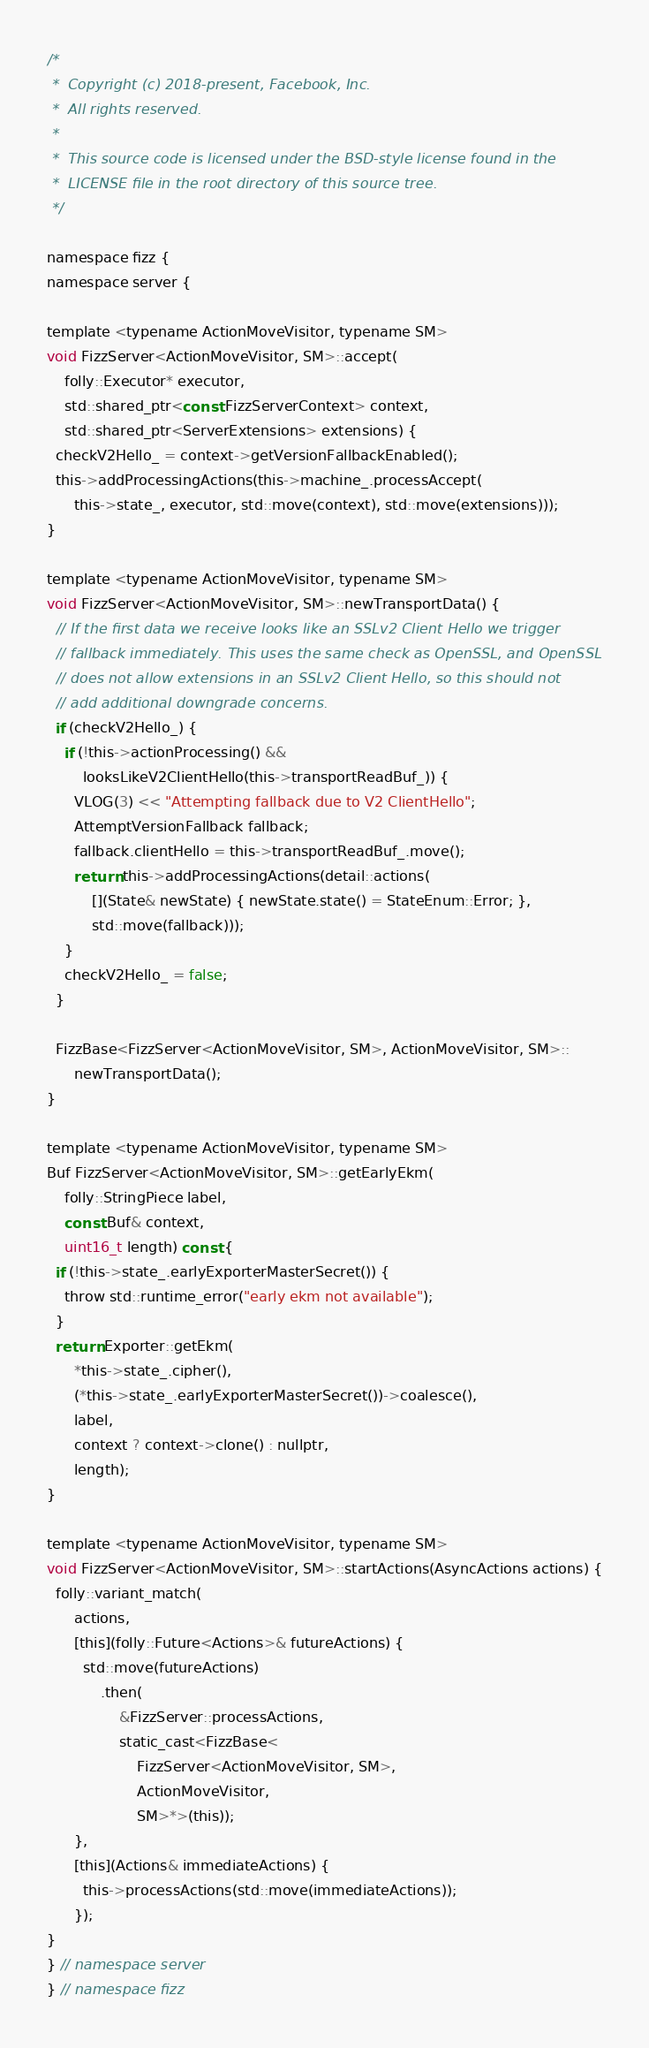Convert code to text. <code><loc_0><loc_0><loc_500><loc_500><_C_>/*
 *  Copyright (c) 2018-present, Facebook, Inc.
 *  All rights reserved.
 *
 *  This source code is licensed under the BSD-style license found in the
 *  LICENSE file in the root directory of this source tree.
 */

namespace fizz {
namespace server {

template <typename ActionMoveVisitor, typename SM>
void FizzServer<ActionMoveVisitor, SM>::accept(
    folly::Executor* executor,
    std::shared_ptr<const FizzServerContext> context,
    std::shared_ptr<ServerExtensions> extensions) {
  checkV2Hello_ = context->getVersionFallbackEnabled();
  this->addProcessingActions(this->machine_.processAccept(
      this->state_, executor, std::move(context), std::move(extensions)));
}

template <typename ActionMoveVisitor, typename SM>
void FizzServer<ActionMoveVisitor, SM>::newTransportData() {
  // If the first data we receive looks like an SSLv2 Client Hello we trigger
  // fallback immediately. This uses the same check as OpenSSL, and OpenSSL
  // does not allow extensions in an SSLv2 Client Hello, so this should not
  // add additional downgrade concerns.
  if (checkV2Hello_) {
    if (!this->actionProcessing() &&
        looksLikeV2ClientHello(this->transportReadBuf_)) {
      VLOG(3) << "Attempting fallback due to V2 ClientHello";
      AttemptVersionFallback fallback;
      fallback.clientHello = this->transportReadBuf_.move();
      return this->addProcessingActions(detail::actions(
          [](State& newState) { newState.state() = StateEnum::Error; },
          std::move(fallback)));
    }
    checkV2Hello_ = false;
  }

  FizzBase<FizzServer<ActionMoveVisitor, SM>, ActionMoveVisitor, SM>::
      newTransportData();
}

template <typename ActionMoveVisitor, typename SM>
Buf FizzServer<ActionMoveVisitor, SM>::getEarlyEkm(
    folly::StringPiece label,
    const Buf& context,
    uint16_t length) const {
  if (!this->state_.earlyExporterMasterSecret()) {
    throw std::runtime_error("early ekm not available");
  }
  return Exporter::getEkm(
      *this->state_.cipher(),
      (*this->state_.earlyExporterMasterSecret())->coalesce(),
      label,
      context ? context->clone() : nullptr,
      length);
}

template <typename ActionMoveVisitor, typename SM>
void FizzServer<ActionMoveVisitor, SM>::startActions(AsyncActions actions) {
  folly::variant_match(
      actions,
      [this](folly::Future<Actions>& futureActions) {
        std::move(futureActions)
            .then(
                &FizzServer::processActions,
                static_cast<FizzBase<
                    FizzServer<ActionMoveVisitor, SM>,
                    ActionMoveVisitor,
                    SM>*>(this));
      },
      [this](Actions& immediateActions) {
        this->processActions(std::move(immediateActions));
      });
}
} // namespace server
} // namespace fizz
</code> 